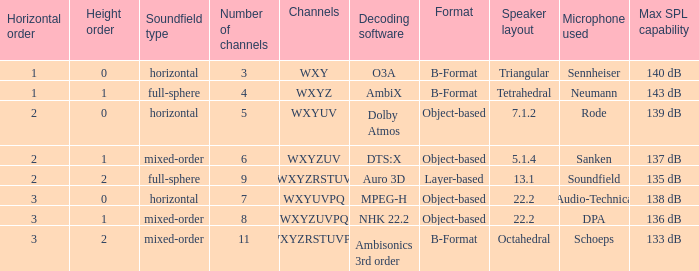I'm looking to parse the entire table for insights. Could you assist me with that? {'header': ['Horizontal order', 'Height order', 'Soundfield type', 'Number of channels', 'Channels', 'Decoding software', 'Format', 'Speaker layout', 'Microphone used', 'Max SPL capability'], 'rows': [['1', '0', 'horizontal', '3', 'WXY', 'O3A', 'B-Format', 'Triangular', 'Sennheiser', '140 dB'], ['1', '1', 'full-sphere', '4', 'WXYZ', 'AmbiX', 'B-Format', 'Tetrahedral', 'Neumann', '143 dB'], ['2', '0', 'horizontal', '5', 'WXYUV', 'Dolby Atmos', 'Object-based', '7.1.2', 'Rode', '139 dB'], ['2', '1', 'mixed-order', '6', 'WXYZUV', 'DTS:X', 'Object-based', '5.1.4', 'Sanken', '137 dB'], ['2', '2', 'full-sphere', '9', 'WXYZRSTUV', 'Auro 3D', 'Layer-based', '13.1', 'Soundfield', '135 dB'], ['3', '0', 'horizontal', '7', 'WXYUVPQ', 'MPEG-H', 'Object-based', '22.2', 'Audio-Technica', '138 dB'], ['3', '1', 'mixed-order', '8', 'WXYZUVPQ', 'NHK 22.2', 'Object-based', '22.2', 'DPA', '136 dB'], ['3', '2', 'mixed-order', '11', 'WXYZRSTUVPQ', 'Ambisonics 3rd order', 'B-Format', 'Octahedral', 'Schoeps', '133 dB']]} If the height order is 1 and the soundfield type is mixed-order, what are all the channels? WXYZUV, WXYZUVPQ. 